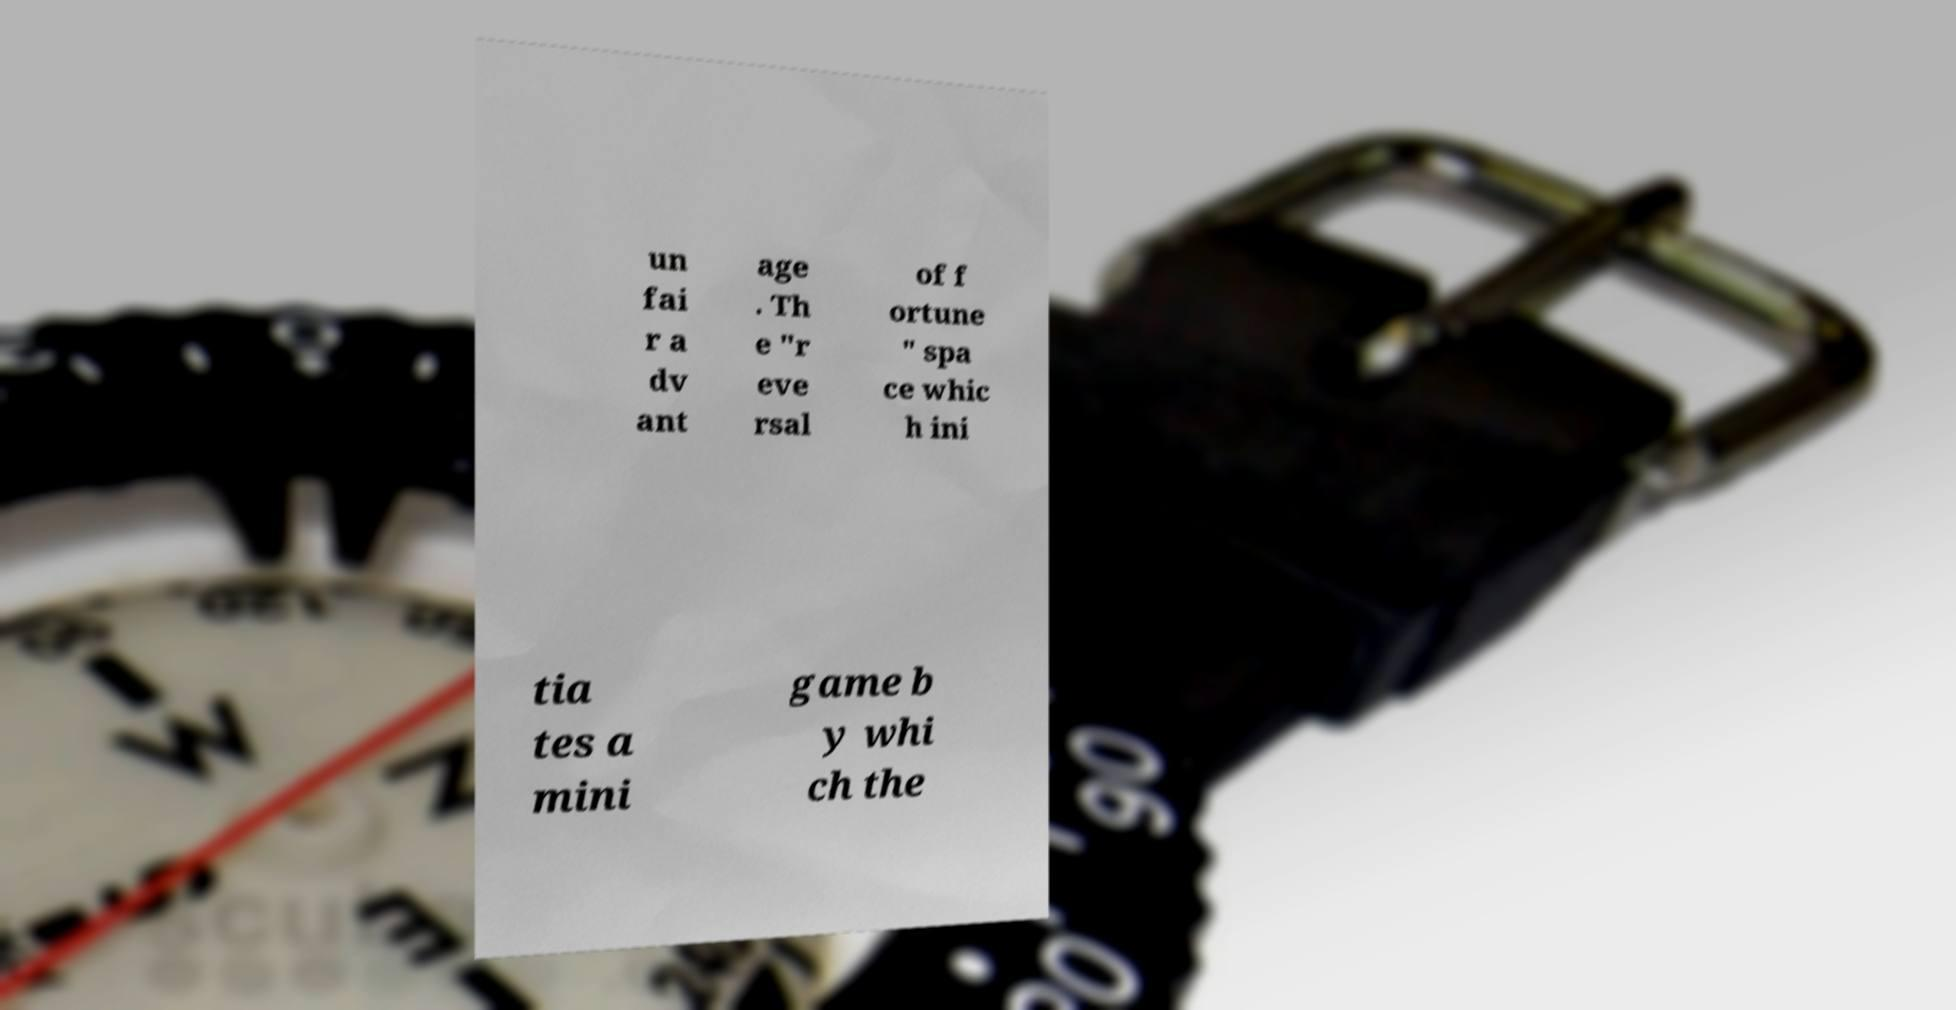What messages or text are displayed in this image? I need them in a readable, typed format. un fai r a dv ant age . Th e "r eve rsal of f ortune " spa ce whic h ini tia tes a mini game b y whi ch the 